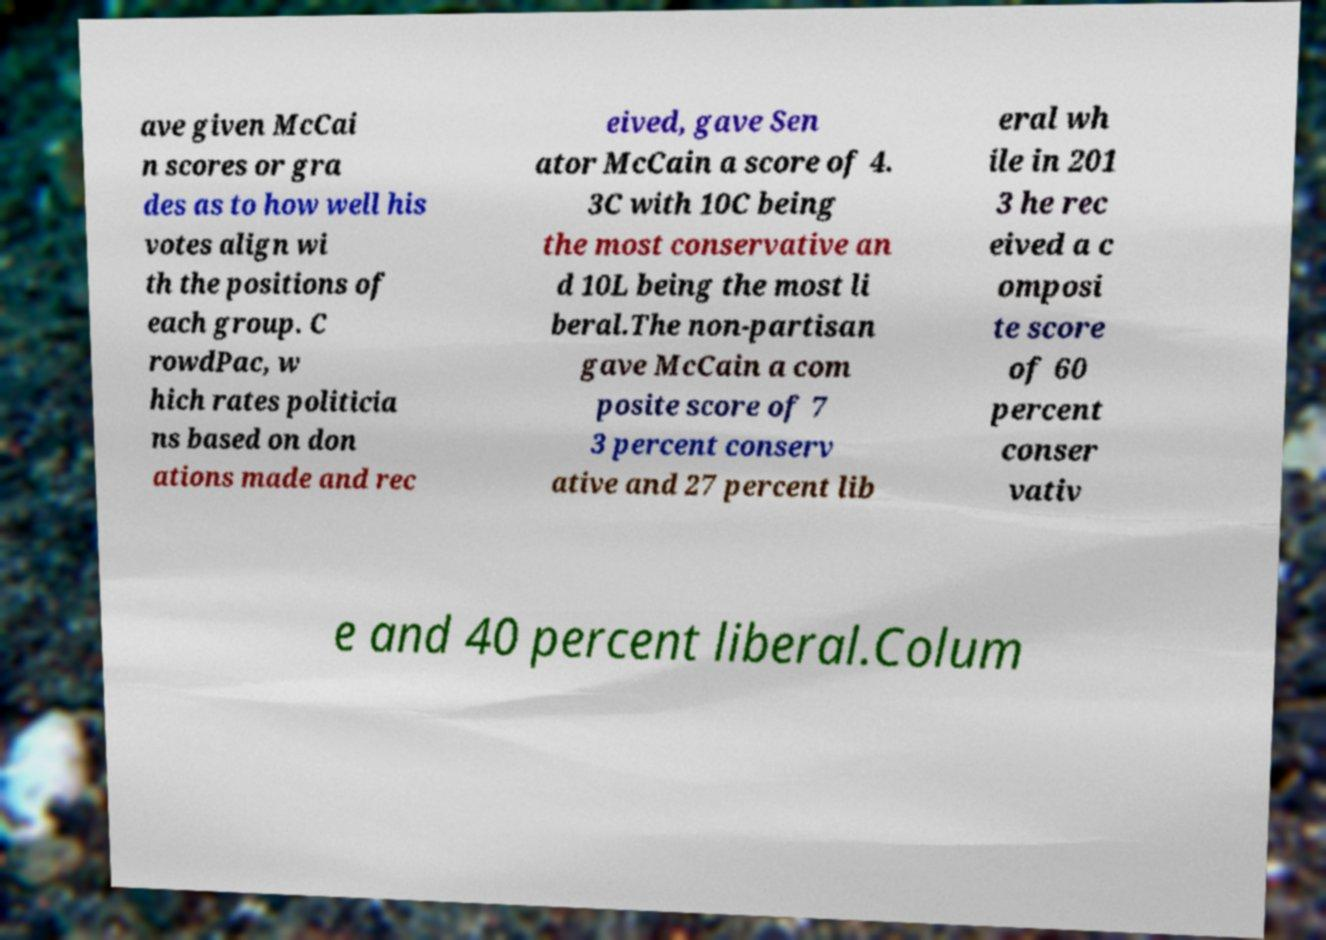For documentation purposes, I need the text within this image transcribed. Could you provide that? ave given McCai n scores or gra des as to how well his votes align wi th the positions of each group. C rowdPac, w hich rates politicia ns based on don ations made and rec eived, gave Sen ator McCain a score of 4. 3C with 10C being the most conservative an d 10L being the most li beral.The non-partisan gave McCain a com posite score of 7 3 percent conserv ative and 27 percent lib eral wh ile in 201 3 he rec eived a c omposi te score of 60 percent conser vativ e and 40 percent liberal.Colum 